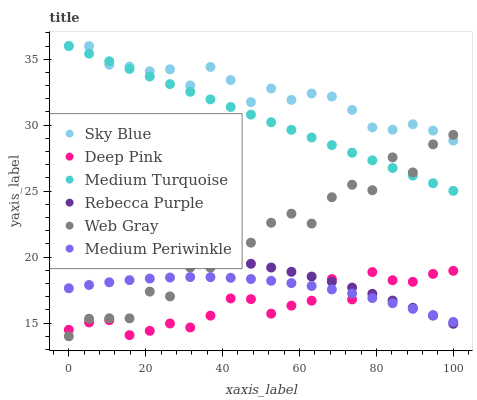Does Deep Pink have the minimum area under the curve?
Answer yes or no. Yes. Does Sky Blue have the maximum area under the curve?
Answer yes or no. Yes. Does Medium Periwinkle have the minimum area under the curve?
Answer yes or no. No. Does Medium Periwinkle have the maximum area under the curve?
Answer yes or no. No. Is Medium Turquoise the smoothest?
Answer yes or no. Yes. Is Web Gray the roughest?
Answer yes or no. Yes. Is Medium Periwinkle the smoothest?
Answer yes or no. No. Is Medium Periwinkle the roughest?
Answer yes or no. No. Does Web Gray have the lowest value?
Answer yes or no. Yes. Does Medium Periwinkle have the lowest value?
Answer yes or no. No. Does Sky Blue have the highest value?
Answer yes or no. Yes. Does Web Gray have the highest value?
Answer yes or no. No. Is Medium Periwinkle less than Sky Blue?
Answer yes or no. Yes. Is Sky Blue greater than Medium Periwinkle?
Answer yes or no. Yes. Does Rebecca Purple intersect Deep Pink?
Answer yes or no. Yes. Is Rebecca Purple less than Deep Pink?
Answer yes or no. No. Is Rebecca Purple greater than Deep Pink?
Answer yes or no. No. Does Medium Periwinkle intersect Sky Blue?
Answer yes or no. No. 